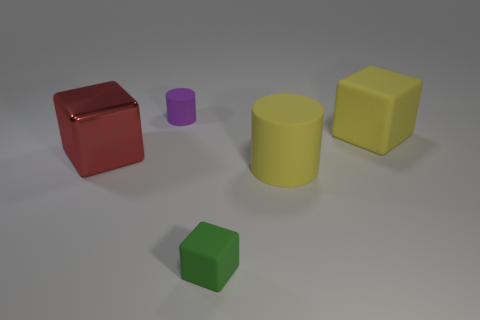Subtract all big blocks. How many blocks are left? 1 Add 3 big red objects. How many objects exist? 8 Subtract all cyan blocks. Subtract all green cylinders. How many blocks are left? 3 Subtract all blocks. How many objects are left? 2 Add 5 big yellow matte objects. How many big yellow matte objects are left? 7 Add 4 tiny cylinders. How many tiny cylinders exist? 5 Subtract 0 red spheres. How many objects are left? 5 Subtract all balls. Subtract all green rubber things. How many objects are left? 4 